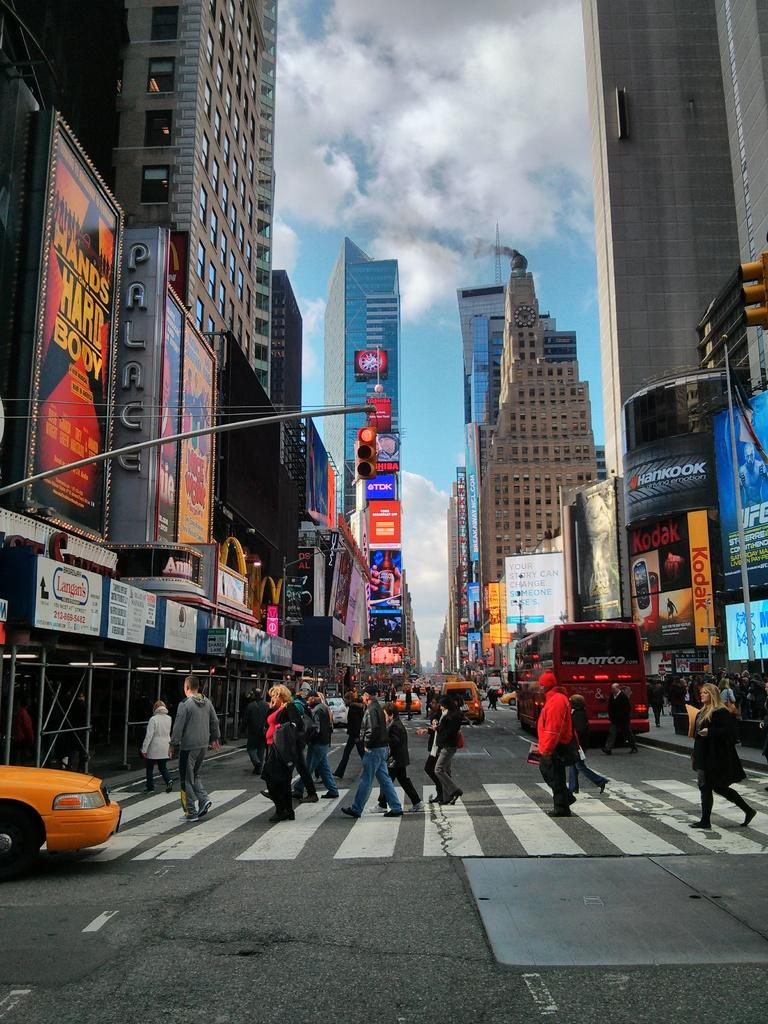<image>
Summarize the visual content of the image. A shot of a busy city street where pedestrians are crossing under a sign that says Palace. 